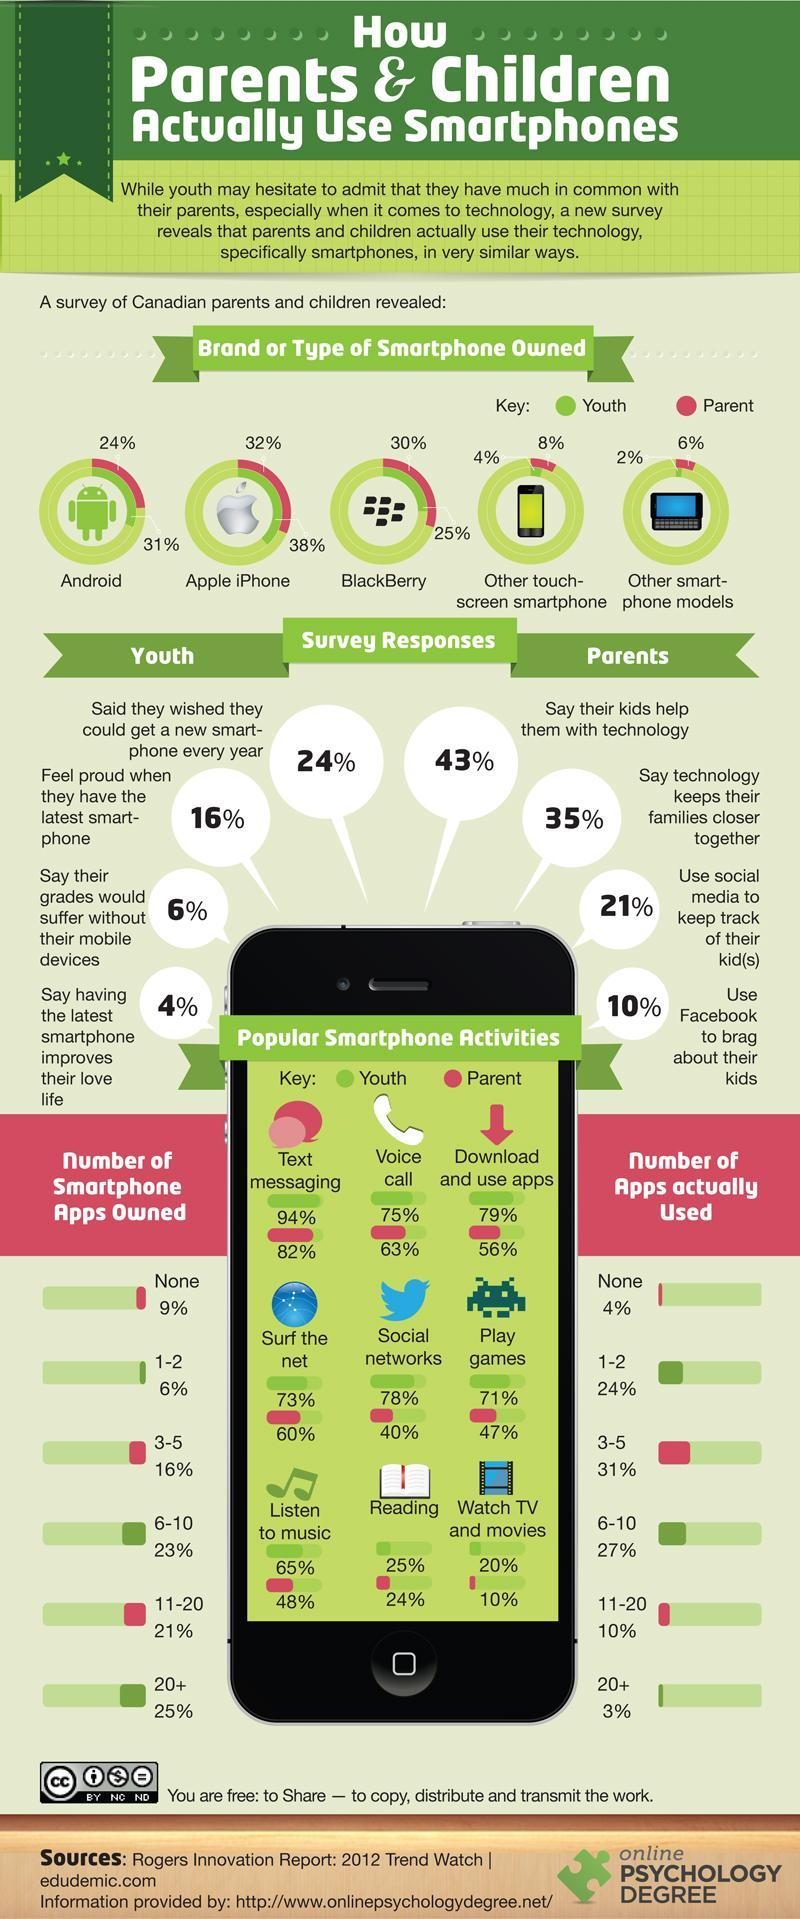What percentage of Canadian parents play games using smartphones as per the survey?
Answer the question with a short phrase. 47% What percentage of the Canadian youth own 20+ number of smartphone apps as per the survey? 25% Which type of smartphone is owned by the majority of the Canadian youth according to the survey? Apple iPhone What percentage of Canadian parents does voice calling using smartphones according to the survey? 63% What percentage of the Canadian parents owned a BlackBerry phone according to the survey? 30% What percent of the Canadian parents doest not have any smartphone apps as per the survey? 9% What percentage of Canadian youth does social networking using smartphones according to the survey? 78% What percentage of the Canadian youth owned Apple iPhone according to the survey? 38% What percentage of Canadian parents listen to music using smartphones as per the survey? 48% 